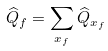Convert formula to latex. <formula><loc_0><loc_0><loc_500><loc_500>\widehat { Q } _ { f } = \sum _ { x _ { f } } \widehat { Q } _ { x _ { f } }</formula> 